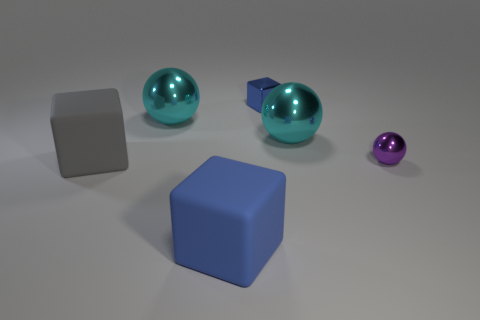What number of cyan spheres are in front of the big metal ball to the left of the blue rubber thing? 1 